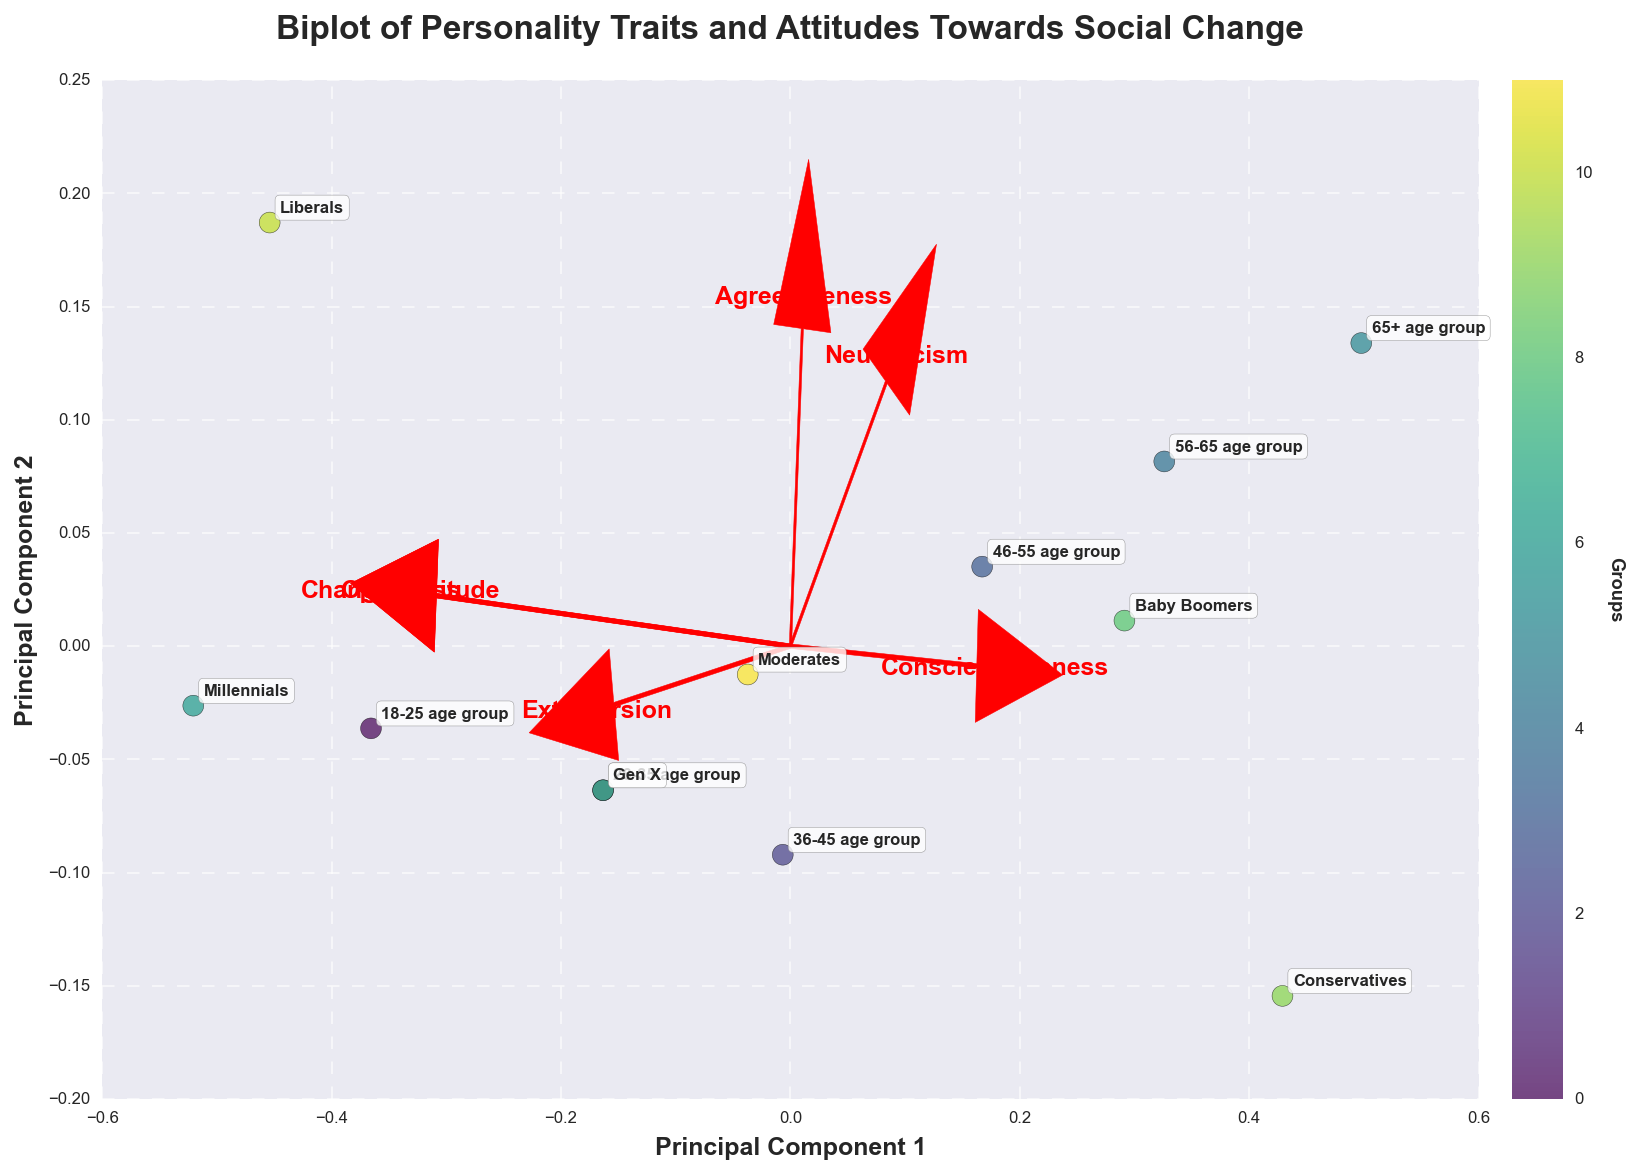What is the title of the biplot? The title is displayed at the top center of the plot in bold and large font. It narrates the essence of the biplot content.
Answer: Biplot of Personality Traits and Attitudes Towards Social Change What are the two principal components labeled on the axes? The axes are labeled horizontally and vertically, each representing a principal component extracted from the PCA. They are essential in illustrating the data variance in two dimensions.
Answer: Principal Component 1 and Principal Component 2 Which age group is closest to the highest Change_Attitude vector direction? By looking at where the Change_Attitude arrow points and the nearby data points, we can deduce which age group aligns closest with this arrow.
Answer: 18-25 age group Which group has the highest Openness value? To identify this, locate the direction in which the Openness vector points and find the data point farthest in that direction.
Answer: Millennials Compare the Conscientiousness values of Baby Boomers and Gen X. Which is higher? Examine the plot to see which direction the Conscientiousness vector points in, then check the positions of Baby Boomers and Gen X in that dimension.
Answer: Baby Boomers Which vector is oriented negatively on Principal Component 1? This requires looking at the vectors and determining which one has an arrow pointing toward negative values in the Principal Component 1 direction.
Answer: Openness Explain the position of Liberals in terms of Agreeableness and Change_Attitude. Locate the coordinates of Liberals in relation to the vectors for Agreeableness and Change_Attitude. Note if it lies above, below, or near these vectors, indicating higher values.
Answer: High in both Agreeableness and Change_Attitude Are Millennials and Liberals overlapping or separate entities on the plot? By focusing on the exact positions of Millennials and Liberals, determine if they share the same spot or are distinctively apart on the plot.
Answer: Overlapping Which group has the highest value in Neuroticism among the provided groups? Observe the Neuroticism vector and its furthest point, correlating it to the corresponding group names near the end.
Answer: 65+ age group 